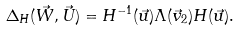Convert formula to latex. <formula><loc_0><loc_0><loc_500><loc_500>\Delta _ { H } ( \vec { W } , \vec { U } ) = H ^ { - 1 } ( \vec { u } ) \Lambda ( \vec { v } _ { 2 } ) H ( \vec { u } ) .</formula> 